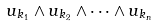Convert formula to latex. <formula><loc_0><loc_0><loc_500><loc_500>u _ { k _ { 1 } } \wedge u _ { k _ { 2 } } \wedge \cdots \wedge u _ { k _ { n } }</formula> 